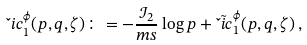Convert formula to latex. <formula><loc_0><loc_0><loc_500><loc_500>\L i c _ { 1 } ^ { \phi } ( p , q , \zeta ) \colon = - \frac { \mathcal { I } _ { 2 } } { m s } \log p + { \tilde { \L i c } } _ { 1 } ^ { \phi } ( p , q , \zeta ) \, ,</formula> 